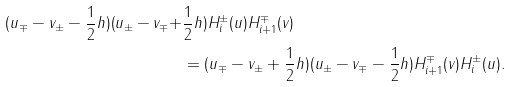<formula> <loc_0><loc_0><loc_500><loc_500>( u _ { \mp } - v _ { \pm } - \frac { 1 } { 2 } h ) ( u _ { \pm } - v _ { \mp } + & \frac { 1 } { 2 } h ) H _ { i } ^ { \pm } ( u ) H _ { i + 1 } ^ { \mp } ( v ) \\ & = ( u _ { \mp } - v _ { \pm } + \frac { 1 } { 2 } h ) ( u _ { \pm } - v _ { \mp } - \frac { 1 } { 2 } h ) H _ { i + 1 } ^ { \mp } ( v ) H _ { i } ^ { \pm } ( u ) .</formula> 